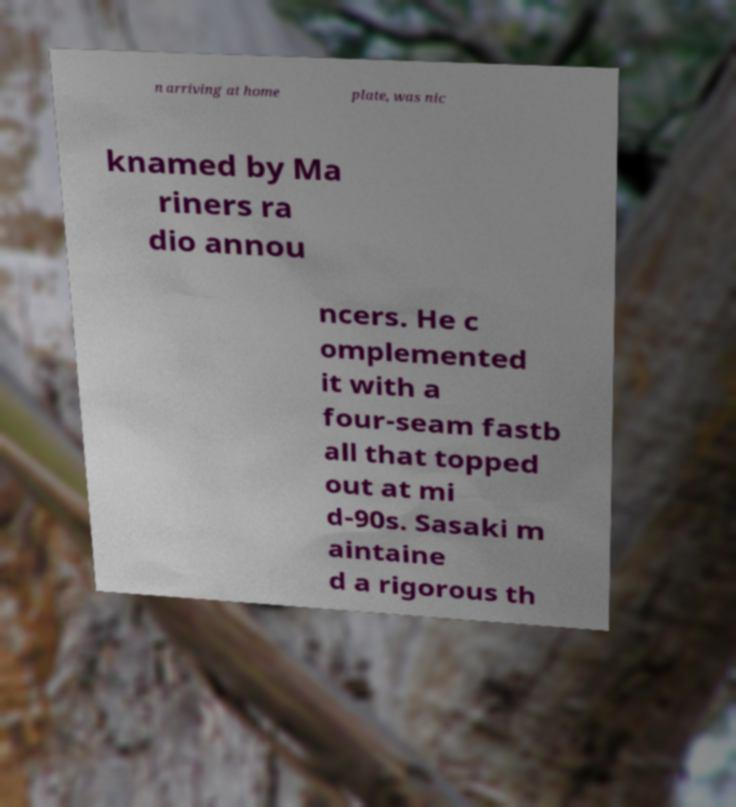Can you accurately transcribe the text from the provided image for me? n arriving at home plate, was nic knamed by Ma riners ra dio annou ncers. He c omplemented it with a four-seam fastb all that topped out at mi d-90s. Sasaki m aintaine d a rigorous th 